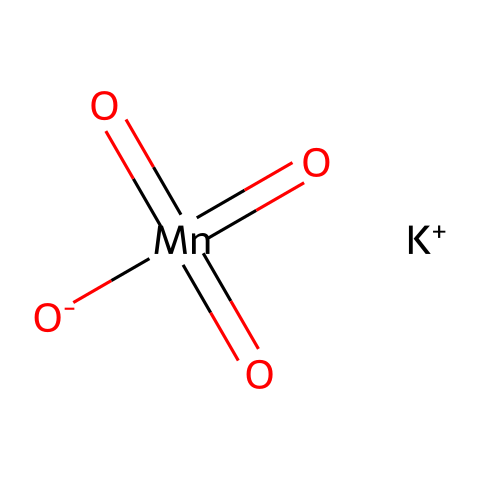What is the main element in potassium permanganate? The main element in potassium permanganate is manganese, which is found in the center of the chemical structure in the form of the Mn atom.
Answer: manganese How many oxygen atoms are present in potassium permanganate? By analyzing the SMILES representation, we can see there are four oxygen atoms indicated by the four [O] symbols in the structure.
Answer: four What is the charge of potassium in this chemical? The potassium in potassium permanganate is represented as [K+], indicating it carries a positive charge.
Answer: positive What is the oxidation state of manganese in potassium permanganate? Manganese in this compound has an oxidation state of +7, as can be deduced from the number of oxygen atoms and their typical oxidation states when combined with manganese.
Answer: +7 Is potassium permanganate considered an oxidizer? Yes, potassium permanganate is classified as a strong oxidizer due to its ability to provide oxygen and react with various substances by gaining electrons.
Answer: yes How many chemical bonds are formed in the structure of potassium permanganate? The structure contains several double bonds between manganese and oxygen, and a single bond connecting potassium; counting gives a total of six bonds.
Answer: six What functional group is indicated by the presence of multiple oxygen atoms in the structure? The presence of multiple oxygen atoms, especially in the context of oxidation, suggests that this chemical behaves as an oxidizing agent, which is a typical feature of oxidizers.
Answer: oxidizing agent 